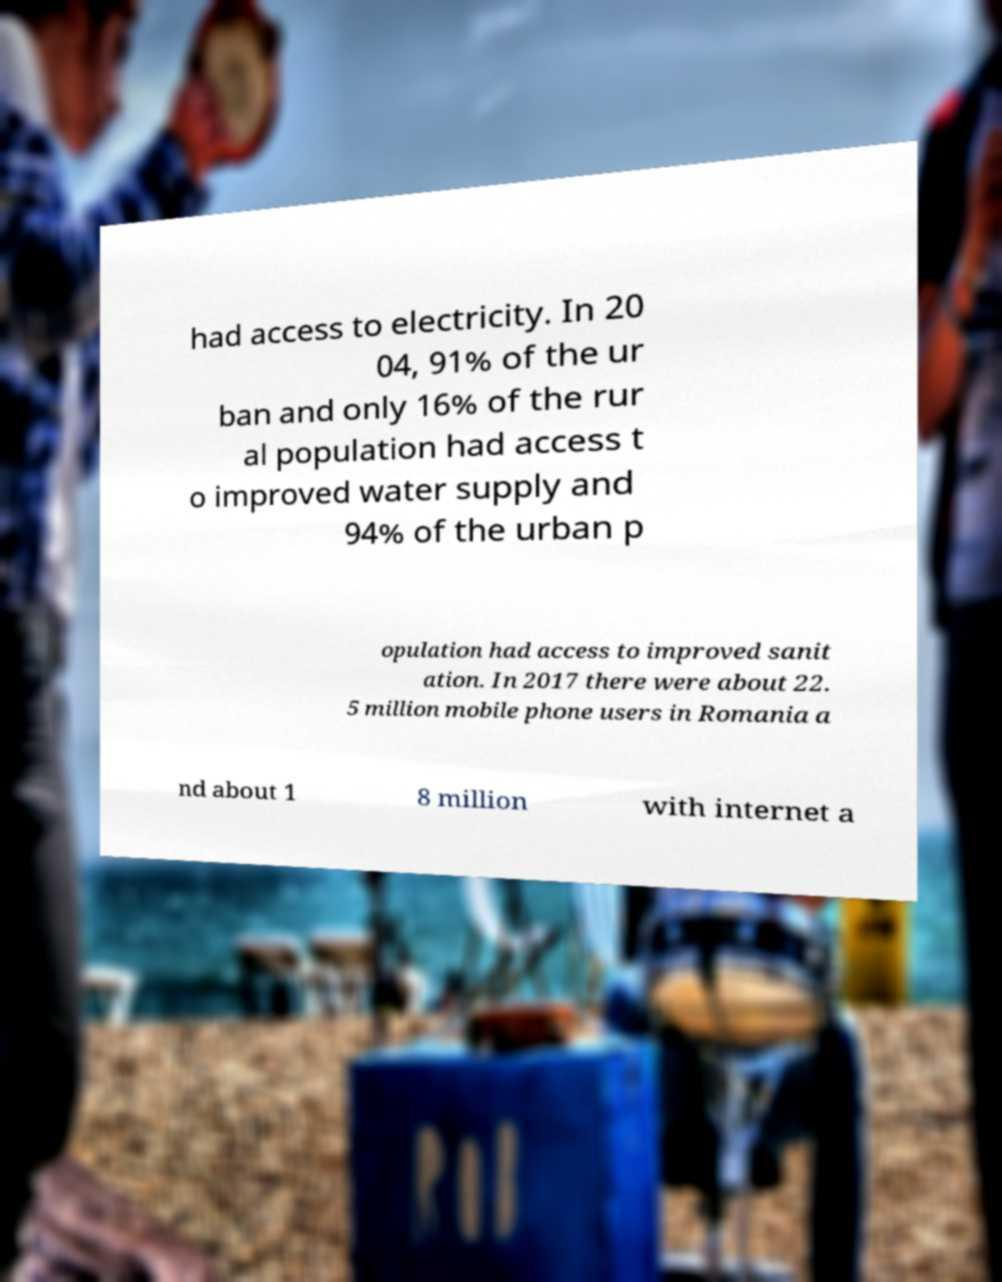Could you extract and type out the text from this image? had access to electricity. In 20 04, 91% of the ur ban and only 16% of the rur al population had access t o improved water supply and 94% of the urban p opulation had access to improved sanit ation. In 2017 there were about 22. 5 million mobile phone users in Romania a nd about 1 8 million with internet a 